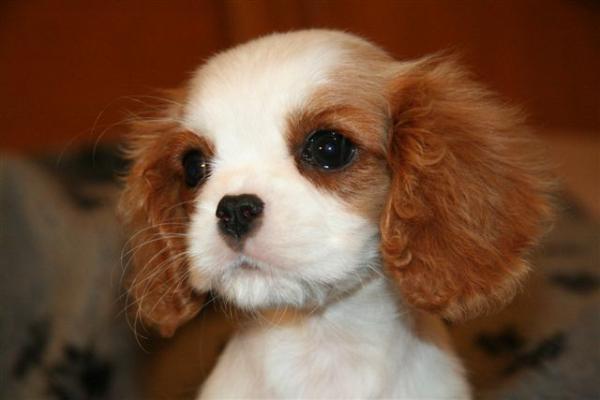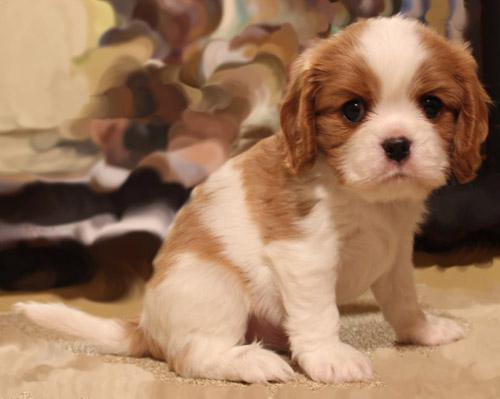The first image is the image on the left, the second image is the image on the right. Examine the images to the left and right. Is the description "There is a body part of a human visible in one of the images." accurate? Answer yes or no. No. The first image is the image on the left, the second image is the image on the right. Assess this claim about the two images: "An image shows one non-standing dog posed in the grass.". Correct or not? Answer yes or no. No. 